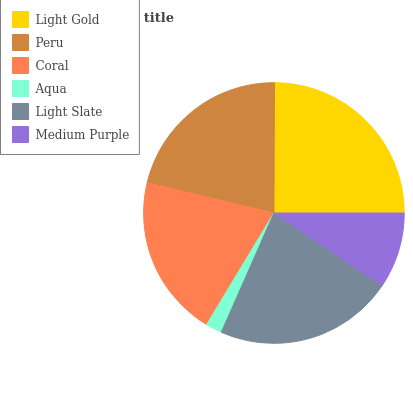Is Aqua the minimum?
Answer yes or no. Yes. Is Light Gold the maximum?
Answer yes or no. Yes. Is Peru the minimum?
Answer yes or no. No. Is Peru the maximum?
Answer yes or no. No. Is Light Gold greater than Peru?
Answer yes or no. Yes. Is Peru less than Light Gold?
Answer yes or no. Yes. Is Peru greater than Light Gold?
Answer yes or no. No. Is Light Gold less than Peru?
Answer yes or no. No. Is Peru the high median?
Answer yes or no. Yes. Is Coral the low median?
Answer yes or no. Yes. Is Medium Purple the high median?
Answer yes or no. No. Is Peru the low median?
Answer yes or no. No. 